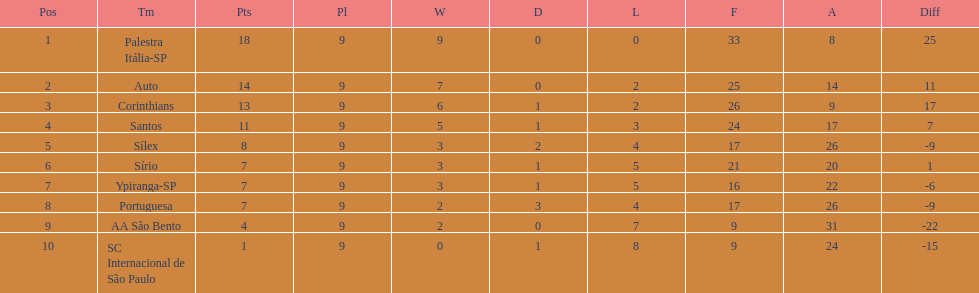In 1926 brazilian football, how many teams scored above 10 points in the season? 4. 